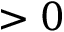Convert formula to latex. <formula><loc_0><loc_0><loc_500><loc_500>> 0</formula> 